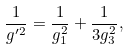<formula> <loc_0><loc_0><loc_500><loc_500>\frac { 1 } { g ^ { \prime 2 } } = \frac { 1 } { g _ { 1 } ^ { 2 } } + \frac { 1 } { 3 g _ { 3 } ^ { 2 } } ,</formula> 